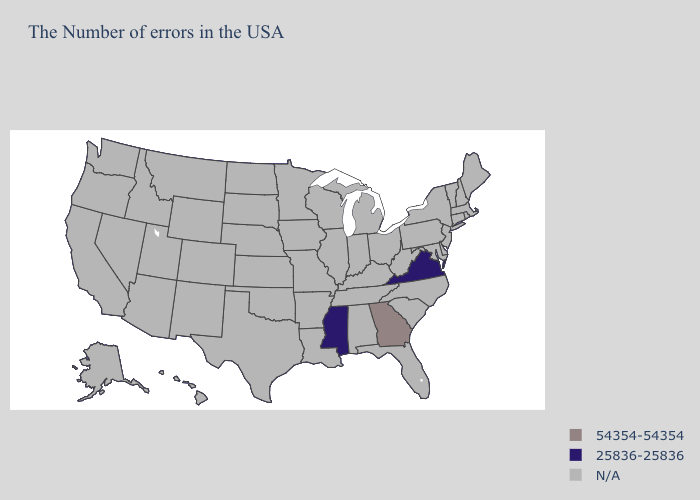Name the states that have a value in the range 25836-25836?
Write a very short answer. Virginia, Mississippi. What is the value of Minnesota?
Keep it brief. N/A. Name the states that have a value in the range 54354-54354?
Quick response, please. Georgia. How many symbols are there in the legend?
Write a very short answer. 3. Name the states that have a value in the range N/A?
Quick response, please. Maine, Massachusetts, Rhode Island, New Hampshire, Vermont, Connecticut, New York, New Jersey, Delaware, Maryland, Pennsylvania, North Carolina, South Carolina, West Virginia, Ohio, Florida, Michigan, Kentucky, Indiana, Alabama, Tennessee, Wisconsin, Illinois, Louisiana, Missouri, Arkansas, Minnesota, Iowa, Kansas, Nebraska, Oklahoma, Texas, South Dakota, North Dakota, Wyoming, Colorado, New Mexico, Utah, Montana, Arizona, Idaho, Nevada, California, Washington, Oregon, Alaska, Hawaii. Name the states that have a value in the range 54354-54354?
Give a very brief answer. Georgia. Name the states that have a value in the range 25836-25836?
Answer briefly. Virginia, Mississippi. What is the value of Alabama?
Short answer required. N/A. What is the lowest value in the USA?
Concise answer only. 25836-25836. What is the value of Hawaii?
Concise answer only. N/A. Does Mississippi have the highest value in the USA?
Answer briefly. No. Does Georgia have the highest value in the USA?
Be succinct. Yes. 